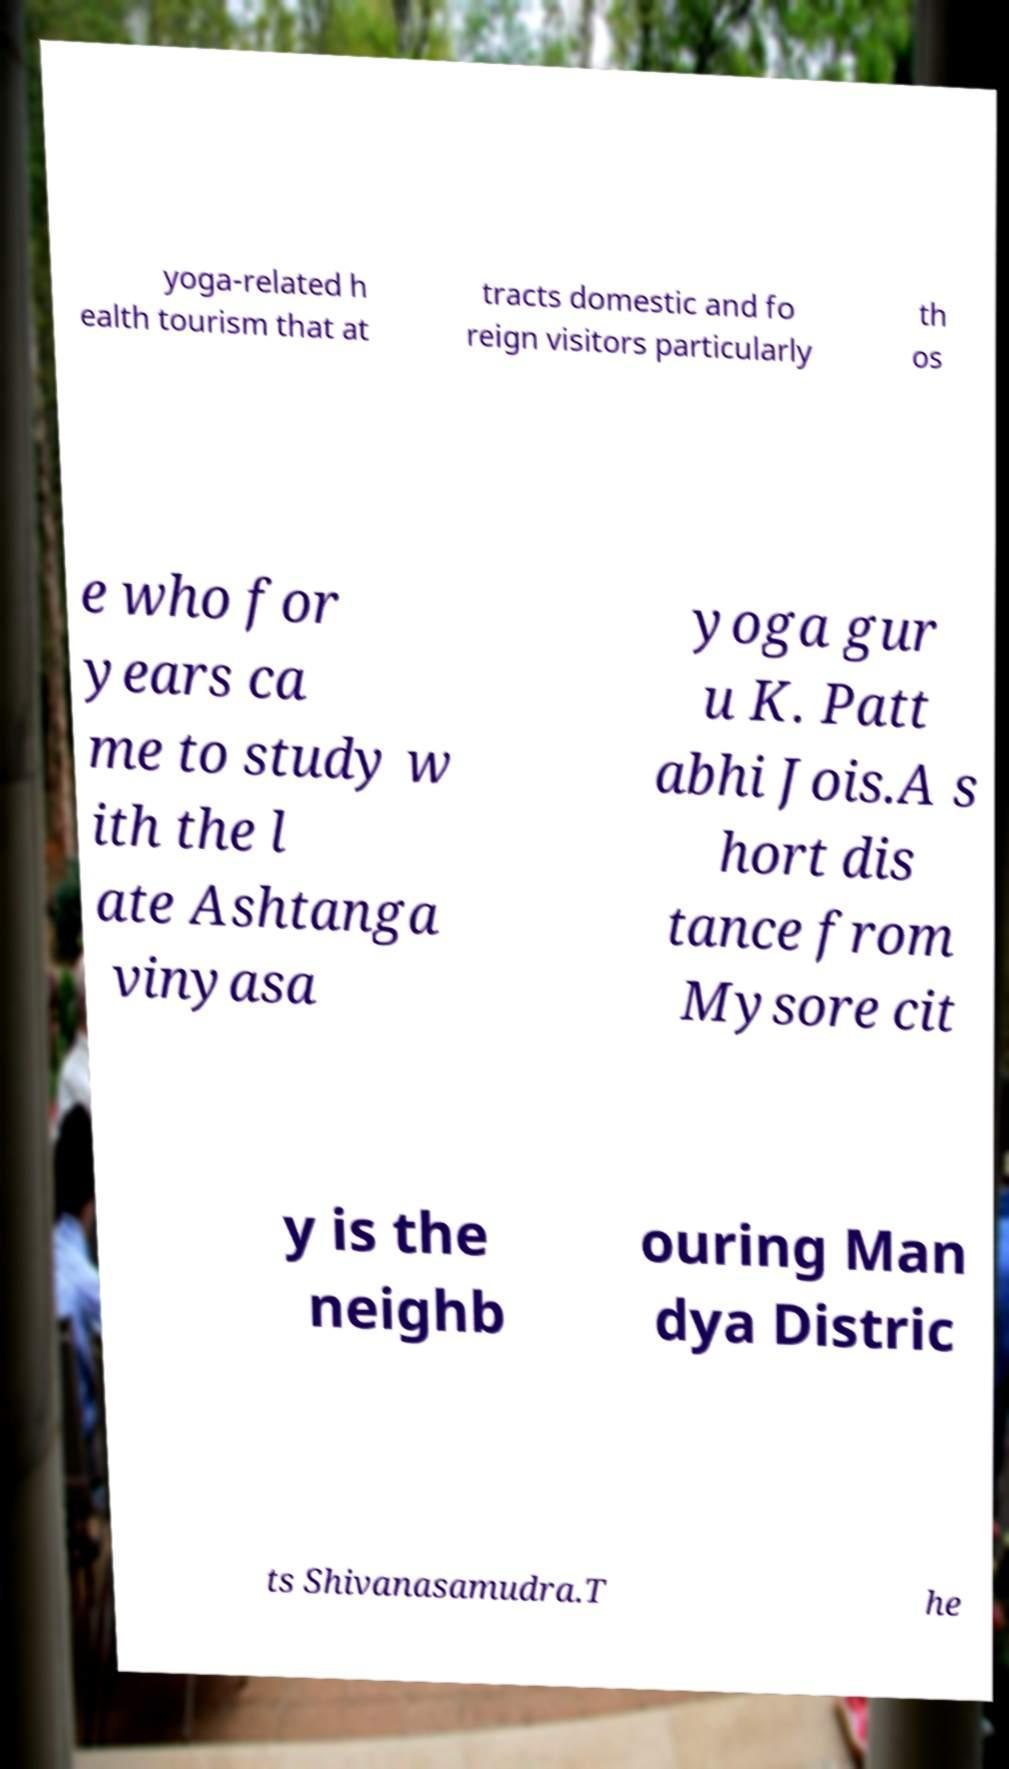For documentation purposes, I need the text within this image transcribed. Could you provide that? yoga-related h ealth tourism that at tracts domestic and fo reign visitors particularly th os e who for years ca me to study w ith the l ate Ashtanga vinyasa yoga gur u K. Patt abhi Jois.A s hort dis tance from Mysore cit y is the neighb ouring Man dya Distric ts Shivanasamudra.T he 